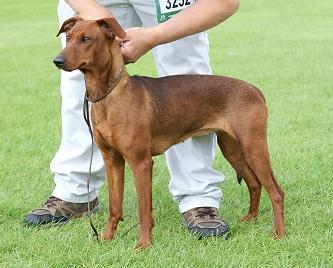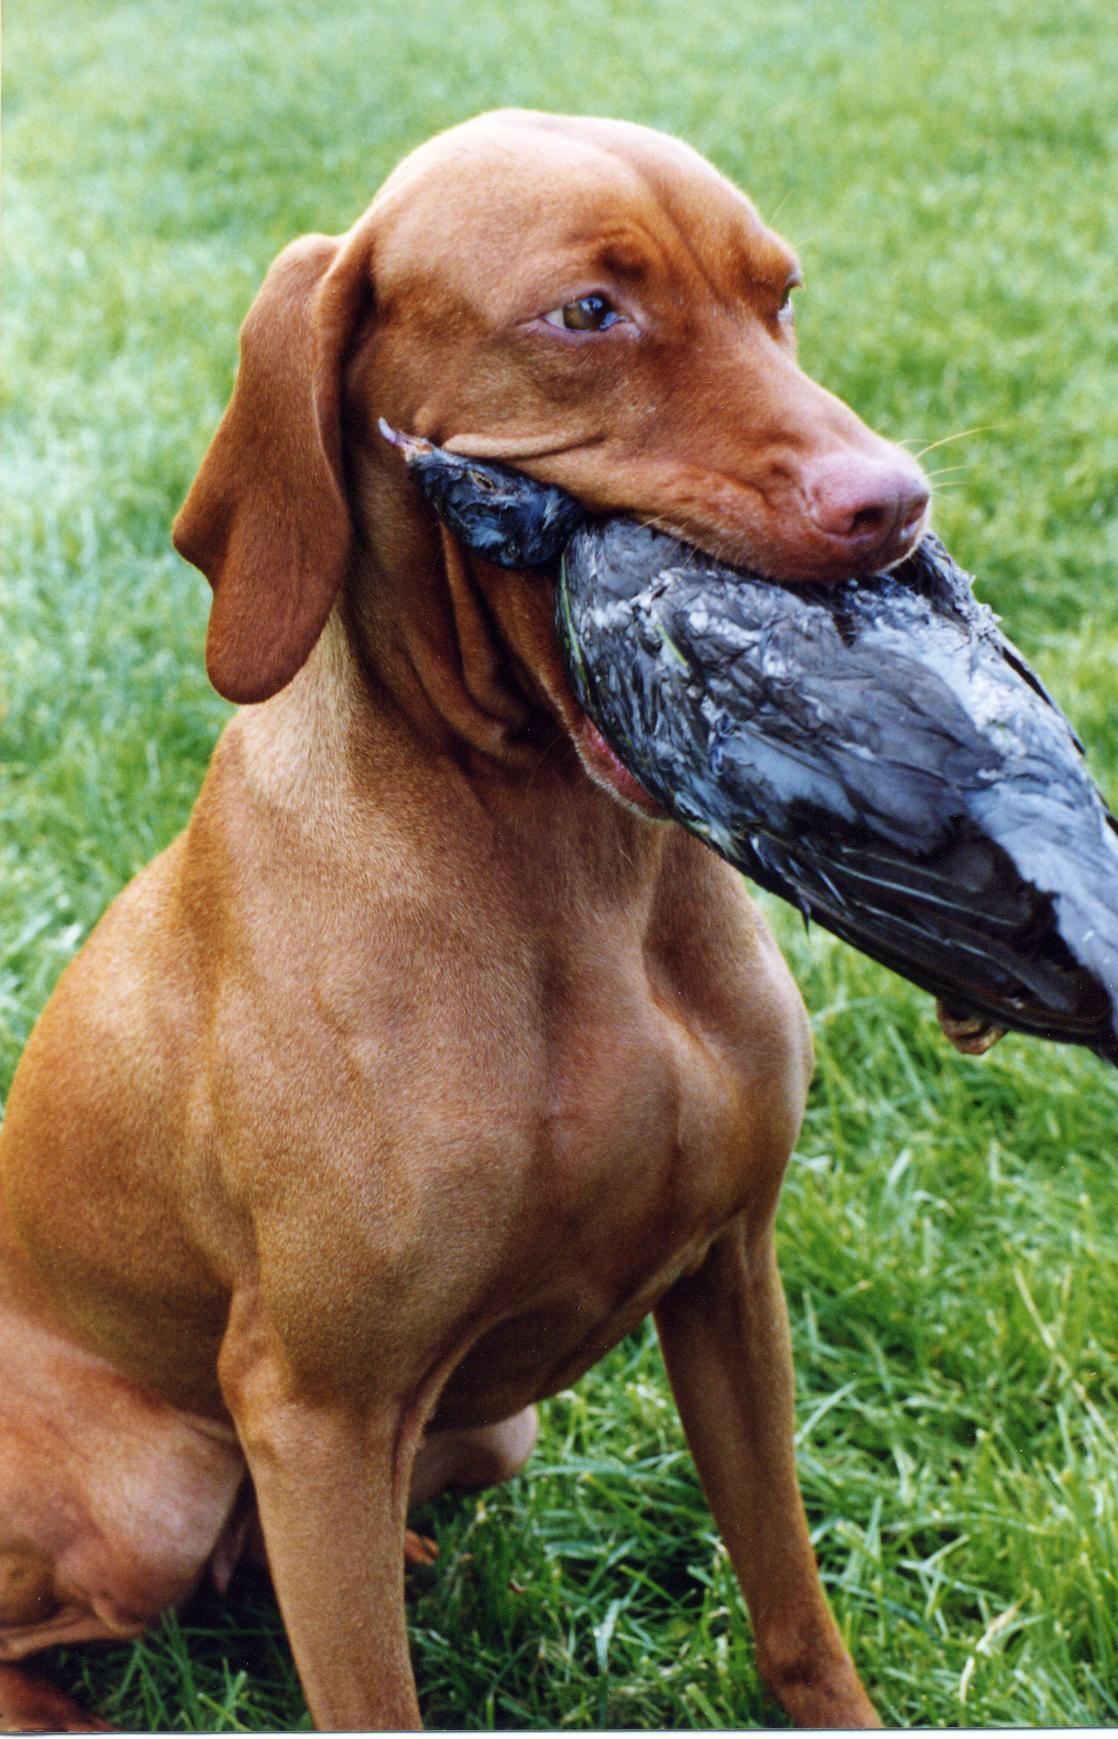The first image is the image on the left, the second image is the image on the right. For the images shown, is this caption "At least one dog has its mouth open." true? Answer yes or no. Yes. 